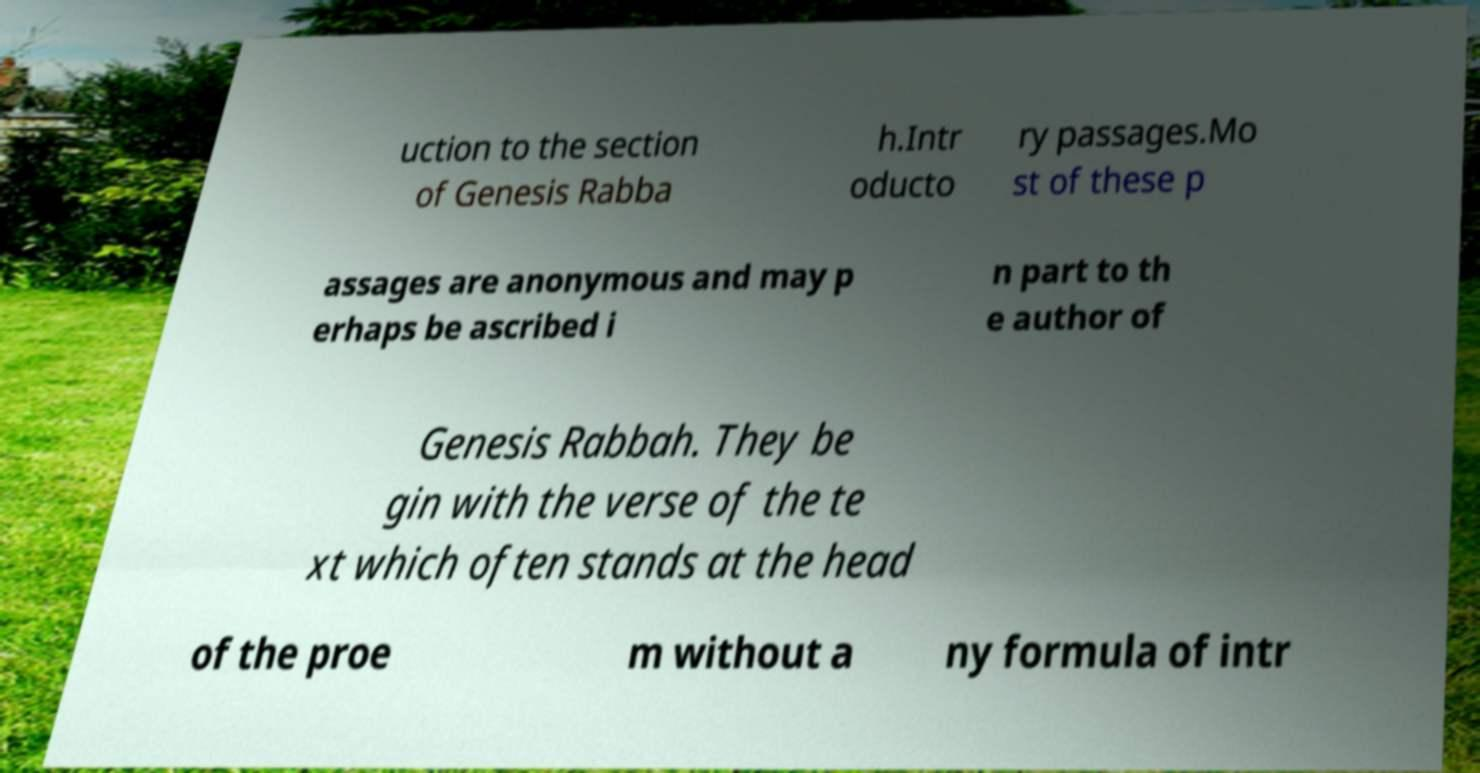Can you accurately transcribe the text from the provided image for me? uction to the section of Genesis Rabba h.Intr oducto ry passages.Mo st of these p assages are anonymous and may p erhaps be ascribed i n part to th e author of Genesis Rabbah. They be gin with the verse of the te xt which often stands at the head of the proe m without a ny formula of intr 